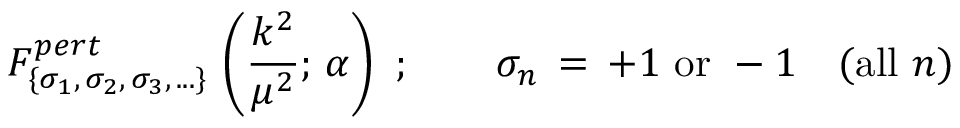Convert formula to latex. <formula><loc_0><loc_0><loc_500><loc_500>F _ { \{ \sigma _ { 1 } , \, \sigma _ { 2 } , \, \sigma _ { 3 } , \, \dots \} } ^ { p e r t } \, \left ( \frac { k ^ { 2 } } { \mu ^ { 2 } } ; \, \alpha \right ) \, ; \quad \sigma _ { n } \, = \, + 1 \, o r \, - 1 \quad ( a l l \, n )</formula> 